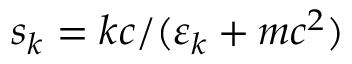<formula> <loc_0><loc_0><loc_500><loc_500>s _ { k } = k c / ( \varepsilon _ { k } + m c ^ { 2 } )</formula> 